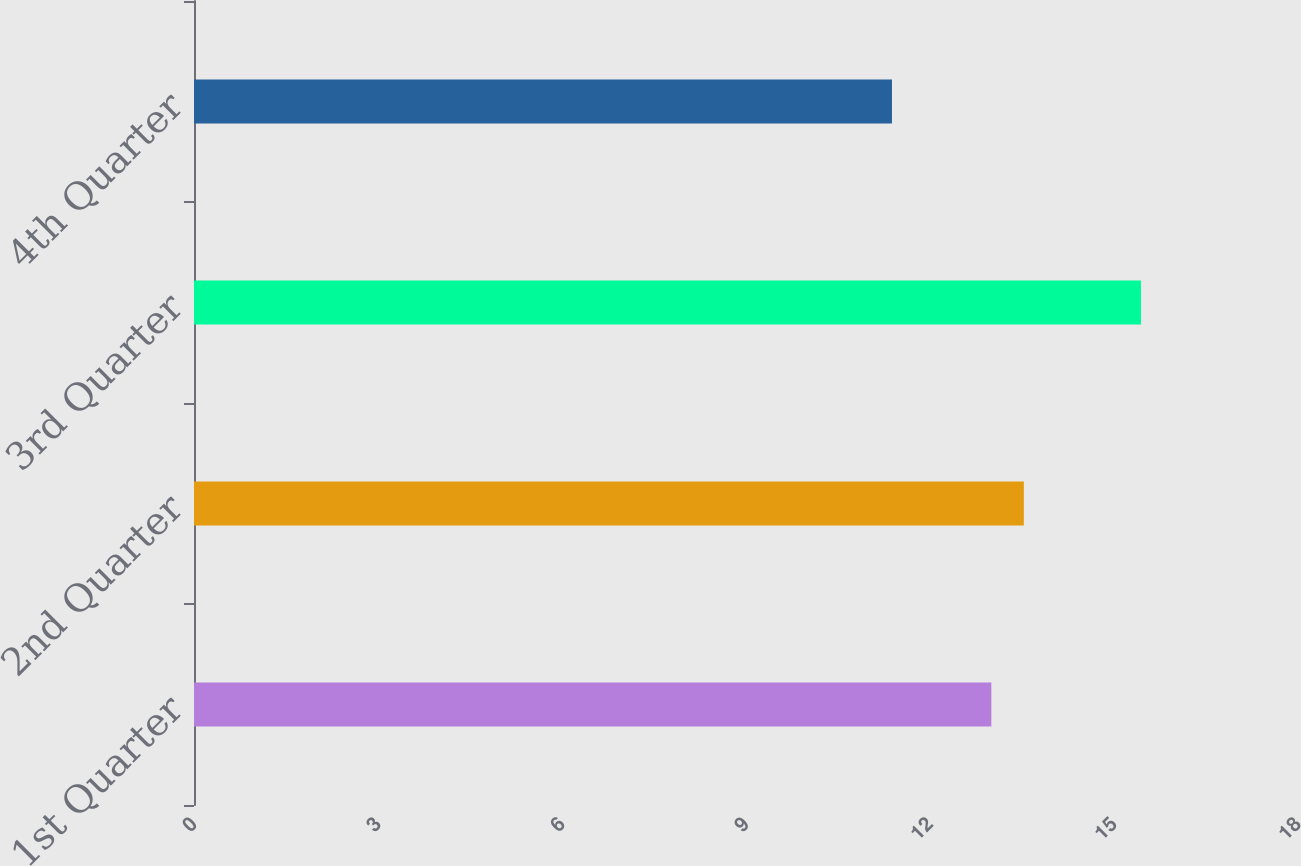<chart> <loc_0><loc_0><loc_500><loc_500><bar_chart><fcel>1st Quarter<fcel>2nd Quarter<fcel>3rd Quarter<fcel>4th Quarter<nl><fcel>13<fcel>13.53<fcel>15.44<fcel>11.38<nl></chart> 